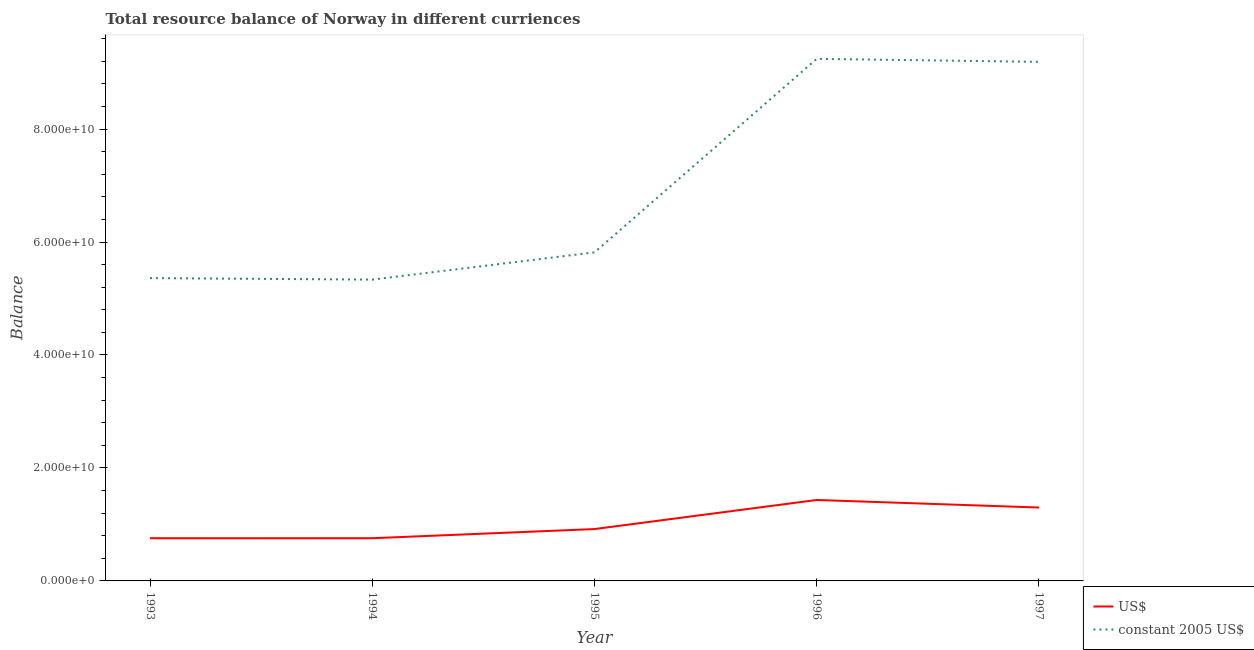Does the line corresponding to resource balance in us$ intersect with the line corresponding to resource balance in constant us$?
Give a very brief answer. No. Is the number of lines equal to the number of legend labels?
Offer a terse response. Yes. What is the resource balance in constant us$ in 1997?
Ensure brevity in your answer.  9.19e+1. Across all years, what is the maximum resource balance in us$?
Offer a very short reply. 1.43e+1. Across all years, what is the minimum resource balance in constant us$?
Provide a succinct answer. 5.34e+1. In which year was the resource balance in constant us$ minimum?
Offer a terse response. 1994. What is the total resource balance in us$ in the graph?
Ensure brevity in your answer.  5.16e+1. What is the difference between the resource balance in constant us$ in 1993 and that in 1994?
Offer a very short reply. 2.60e+08. What is the difference between the resource balance in constant us$ in 1997 and the resource balance in us$ in 1993?
Provide a succinct answer. 8.43e+1. What is the average resource balance in us$ per year?
Provide a succinct answer. 1.03e+1. In the year 1996, what is the difference between the resource balance in constant us$ and resource balance in us$?
Keep it short and to the point. 7.81e+1. In how many years, is the resource balance in constant us$ greater than 64000000000 units?
Keep it short and to the point. 2. What is the ratio of the resource balance in constant us$ in 1995 to that in 1997?
Give a very brief answer. 0.63. Is the difference between the resource balance in constant us$ in 1993 and 1996 greater than the difference between the resource balance in us$ in 1993 and 1996?
Offer a terse response. No. What is the difference between the highest and the second highest resource balance in us$?
Your response must be concise. 1.34e+09. What is the difference between the highest and the lowest resource balance in constant us$?
Give a very brief answer. 3.91e+1. Is the sum of the resource balance in us$ in 1996 and 1997 greater than the maximum resource balance in constant us$ across all years?
Offer a terse response. No. Does the resource balance in us$ monotonically increase over the years?
Offer a very short reply. No. Is the resource balance in us$ strictly less than the resource balance in constant us$ over the years?
Offer a terse response. Yes. How many lines are there?
Keep it short and to the point. 2. How many years are there in the graph?
Offer a very short reply. 5. Are the values on the major ticks of Y-axis written in scientific E-notation?
Your answer should be very brief. Yes. Does the graph contain any zero values?
Your answer should be compact. No. Does the graph contain grids?
Keep it short and to the point. No. Where does the legend appear in the graph?
Offer a terse response. Bottom right. How are the legend labels stacked?
Offer a terse response. Vertical. What is the title of the graph?
Give a very brief answer. Total resource balance of Norway in different curriences. Does "From World Bank" appear as one of the legend labels in the graph?
Ensure brevity in your answer.  No. What is the label or title of the Y-axis?
Your answer should be compact. Balance. What is the Balance in US$ in 1993?
Give a very brief answer. 7.56e+09. What is the Balance in constant 2005 US$ in 1993?
Offer a very short reply. 5.36e+1. What is the Balance in US$ in 1994?
Your response must be concise. 7.56e+09. What is the Balance of constant 2005 US$ in 1994?
Offer a terse response. 5.34e+1. What is the Balance in US$ in 1995?
Offer a very short reply. 9.18e+09. What is the Balance of constant 2005 US$ in 1995?
Offer a very short reply. 5.82e+1. What is the Balance in US$ in 1996?
Your answer should be very brief. 1.43e+1. What is the Balance of constant 2005 US$ in 1996?
Your response must be concise. 9.24e+1. What is the Balance in US$ in 1997?
Keep it short and to the point. 1.30e+1. What is the Balance of constant 2005 US$ in 1997?
Your answer should be very brief. 9.19e+1. Across all years, what is the maximum Balance of US$?
Offer a terse response. 1.43e+1. Across all years, what is the maximum Balance of constant 2005 US$?
Offer a very short reply. 9.24e+1. Across all years, what is the minimum Balance of US$?
Provide a succinct answer. 7.56e+09. Across all years, what is the minimum Balance in constant 2005 US$?
Keep it short and to the point. 5.34e+1. What is the total Balance of US$ in the graph?
Your response must be concise. 5.16e+1. What is the total Balance of constant 2005 US$ in the graph?
Ensure brevity in your answer.  3.49e+11. What is the difference between the Balance in US$ in 1993 and that in 1994?
Provide a succinct answer. -2.24e+06. What is the difference between the Balance of constant 2005 US$ in 1993 and that in 1994?
Your answer should be very brief. 2.60e+08. What is the difference between the Balance in US$ in 1993 and that in 1995?
Offer a very short reply. -1.63e+09. What is the difference between the Balance of constant 2005 US$ in 1993 and that in 1995?
Keep it short and to the point. -4.56e+09. What is the difference between the Balance in US$ in 1993 and that in 1996?
Your answer should be very brief. -6.77e+09. What is the difference between the Balance of constant 2005 US$ in 1993 and that in 1996?
Make the answer very short. -3.88e+1. What is the difference between the Balance of US$ in 1993 and that in 1997?
Keep it short and to the point. -5.44e+09. What is the difference between the Balance of constant 2005 US$ in 1993 and that in 1997?
Offer a very short reply. -3.83e+1. What is the difference between the Balance in US$ in 1994 and that in 1995?
Your response must be concise. -1.62e+09. What is the difference between the Balance of constant 2005 US$ in 1994 and that in 1995?
Make the answer very short. -4.82e+09. What is the difference between the Balance of US$ in 1994 and that in 1996?
Provide a succinct answer. -6.77e+09. What is the difference between the Balance in constant 2005 US$ in 1994 and that in 1996?
Keep it short and to the point. -3.91e+1. What is the difference between the Balance of US$ in 1994 and that in 1997?
Make the answer very short. -5.43e+09. What is the difference between the Balance of constant 2005 US$ in 1994 and that in 1997?
Ensure brevity in your answer.  -3.85e+1. What is the difference between the Balance of US$ in 1995 and that in 1996?
Provide a succinct answer. -5.15e+09. What is the difference between the Balance in constant 2005 US$ in 1995 and that in 1996?
Provide a succinct answer. -3.43e+1. What is the difference between the Balance of US$ in 1995 and that in 1997?
Make the answer very short. -3.81e+09. What is the difference between the Balance in constant 2005 US$ in 1995 and that in 1997?
Your response must be concise. -3.37e+1. What is the difference between the Balance of US$ in 1996 and that in 1997?
Provide a succinct answer. 1.34e+09. What is the difference between the Balance of constant 2005 US$ in 1996 and that in 1997?
Keep it short and to the point. 5.34e+08. What is the difference between the Balance in US$ in 1993 and the Balance in constant 2005 US$ in 1994?
Give a very brief answer. -4.58e+1. What is the difference between the Balance in US$ in 1993 and the Balance in constant 2005 US$ in 1995?
Your answer should be very brief. -5.06e+1. What is the difference between the Balance in US$ in 1993 and the Balance in constant 2005 US$ in 1996?
Offer a terse response. -8.49e+1. What is the difference between the Balance of US$ in 1993 and the Balance of constant 2005 US$ in 1997?
Make the answer very short. -8.43e+1. What is the difference between the Balance of US$ in 1994 and the Balance of constant 2005 US$ in 1995?
Give a very brief answer. -5.06e+1. What is the difference between the Balance in US$ in 1994 and the Balance in constant 2005 US$ in 1996?
Provide a succinct answer. -8.49e+1. What is the difference between the Balance in US$ in 1994 and the Balance in constant 2005 US$ in 1997?
Give a very brief answer. -8.43e+1. What is the difference between the Balance of US$ in 1995 and the Balance of constant 2005 US$ in 1996?
Your response must be concise. -8.33e+1. What is the difference between the Balance of US$ in 1995 and the Balance of constant 2005 US$ in 1997?
Make the answer very short. -8.27e+1. What is the difference between the Balance in US$ in 1996 and the Balance in constant 2005 US$ in 1997?
Ensure brevity in your answer.  -7.76e+1. What is the average Balance of US$ per year?
Ensure brevity in your answer.  1.03e+1. What is the average Balance of constant 2005 US$ per year?
Your response must be concise. 6.99e+1. In the year 1993, what is the difference between the Balance of US$ and Balance of constant 2005 US$?
Your answer should be compact. -4.61e+1. In the year 1994, what is the difference between the Balance of US$ and Balance of constant 2005 US$?
Ensure brevity in your answer.  -4.58e+1. In the year 1995, what is the difference between the Balance of US$ and Balance of constant 2005 US$?
Give a very brief answer. -4.90e+1. In the year 1996, what is the difference between the Balance of US$ and Balance of constant 2005 US$?
Ensure brevity in your answer.  -7.81e+1. In the year 1997, what is the difference between the Balance of US$ and Balance of constant 2005 US$?
Make the answer very short. -7.89e+1. What is the ratio of the Balance of US$ in 1993 to that in 1994?
Make the answer very short. 1. What is the ratio of the Balance in US$ in 1993 to that in 1995?
Give a very brief answer. 0.82. What is the ratio of the Balance of constant 2005 US$ in 1993 to that in 1995?
Your response must be concise. 0.92. What is the ratio of the Balance of US$ in 1993 to that in 1996?
Your answer should be compact. 0.53. What is the ratio of the Balance of constant 2005 US$ in 1993 to that in 1996?
Ensure brevity in your answer.  0.58. What is the ratio of the Balance in US$ in 1993 to that in 1997?
Offer a very short reply. 0.58. What is the ratio of the Balance in constant 2005 US$ in 1993 to that in 1997?
Your answer should be compact. 0.58. What is the ratio of the Balance of US$ in 1994 to that in 1995?
Your response must be concise. 0.82. What is the ratio of the Balance in constant 2005 US$ in 1994 to that in 1995?
Provide a short and direct response. 0.92. What is the ratio of the Balance of US$ in 1994 to that in 1996?
Your answer should be compact. 0.53. What is the ratio of the Balance in constant 2005 US$ in 1994 to that in 1996?
Provide a short and direct response. 0.58. What is the ratio of the Balance of US$ in 1994 to that in 1997?
Offer a terse response. 0.58. What is the ratio of the Balance in constant 2005 US$ in 1994 to that in 1997?
Provide a short and direct response. 0.58. What is the ratio of the Balance in US$ in 1995 to that in 1996?
Keep it short and to the point. 0.64. What is the ratio of the Balance in constant 2005 US$ in 1995 to that in 1996?
Give a very brief answer. 0.63. What is the ratio of the Balance in US$ in 1995 to that in 1997?
Provide a short and direct response. 0.71. What is the ratio of the Balance of constant 2005 US$ in 1995 to that in 1997?
Offer a very short reply. 0.63. What is the ratio of the Balance in US$ in 1996 to that in 1997?
Offer a very short reply. 1.1. What is the ratio of the Balance of constant 2005 US$ in 1996 to that in 1997?
Your response must be concise. 1.01. What is the difference between the highest and the second highest Balance in US$?
Provide a short and direct response. 1.34e+09. What is the difference between the highest and the second highest Balance of constant 2005 US$?
Provide a short and direct response. 5.34e+08. What is the difference between the highest and the lowest Balance of US$?
Ensure brevity in your answer.  6.77e+09. What is the difference between the highest and the lowest Balance of constant 2005 US$?
Give a very brief answer. 3.91e+1. 